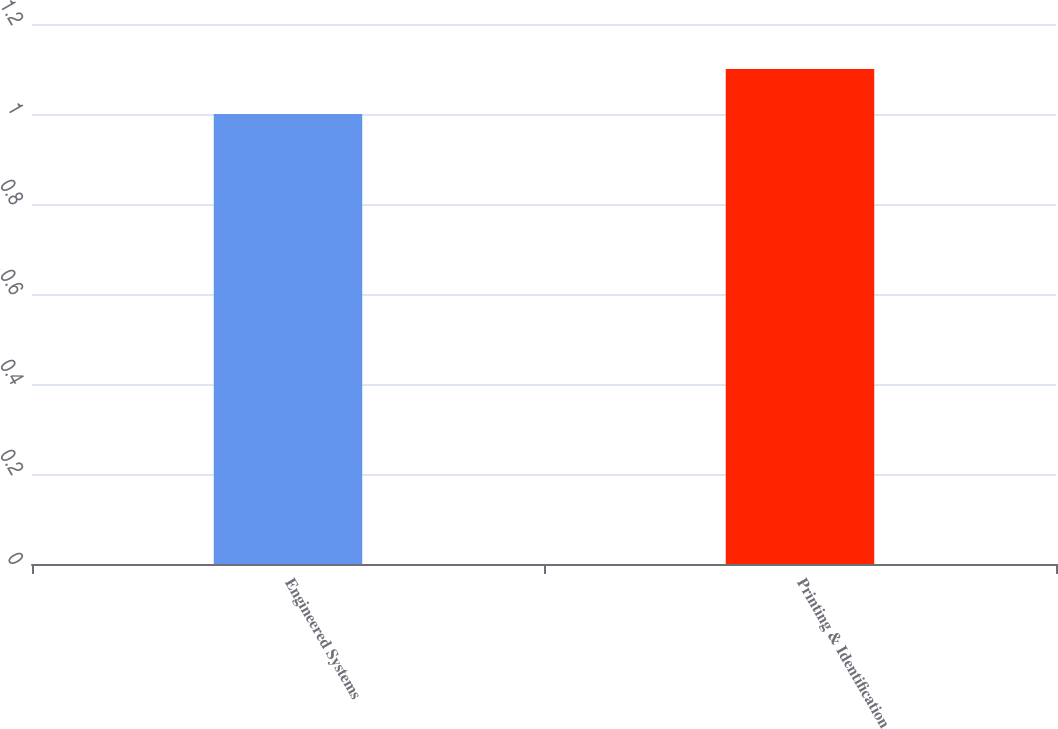<chart> <loc_0><loc_0><loc_500><loc_500><bar_chart><fcel>Engineered Systems<fcel>Printing & Identification<nl><fcel>1<fcel>1.1<nl></chart> 